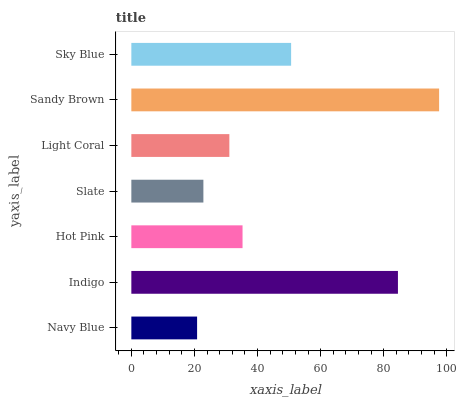Is Navy Blue the minimum?
Answer yes or no. Yes. Is Sandy Brown the maximum?
Answer yes or no. Yes. Is Indigo the minimum?
Answer yes or no. No. Is Indigo the maximum?
Answer yes or no. No. Is Indigo greater than Navy Blue?
Answer yes or no. Yes. Is Navy Blue less than Indigo?
Answer yes or no. Yes. Is Navy Blue greater than Indigo?
Answer yes or no. No. Is Indigo less than Navy Blue?
Answer yes or no. No. Is Hot Pink the high median?
Answer yes or no. Yes. Is Hot Pink the low median?
Answer yes or no. Yes. Is Navy Blue the high median?
Answer yes or no. No. Is Sandy Brown the low median?
Answer yes or no. No. 